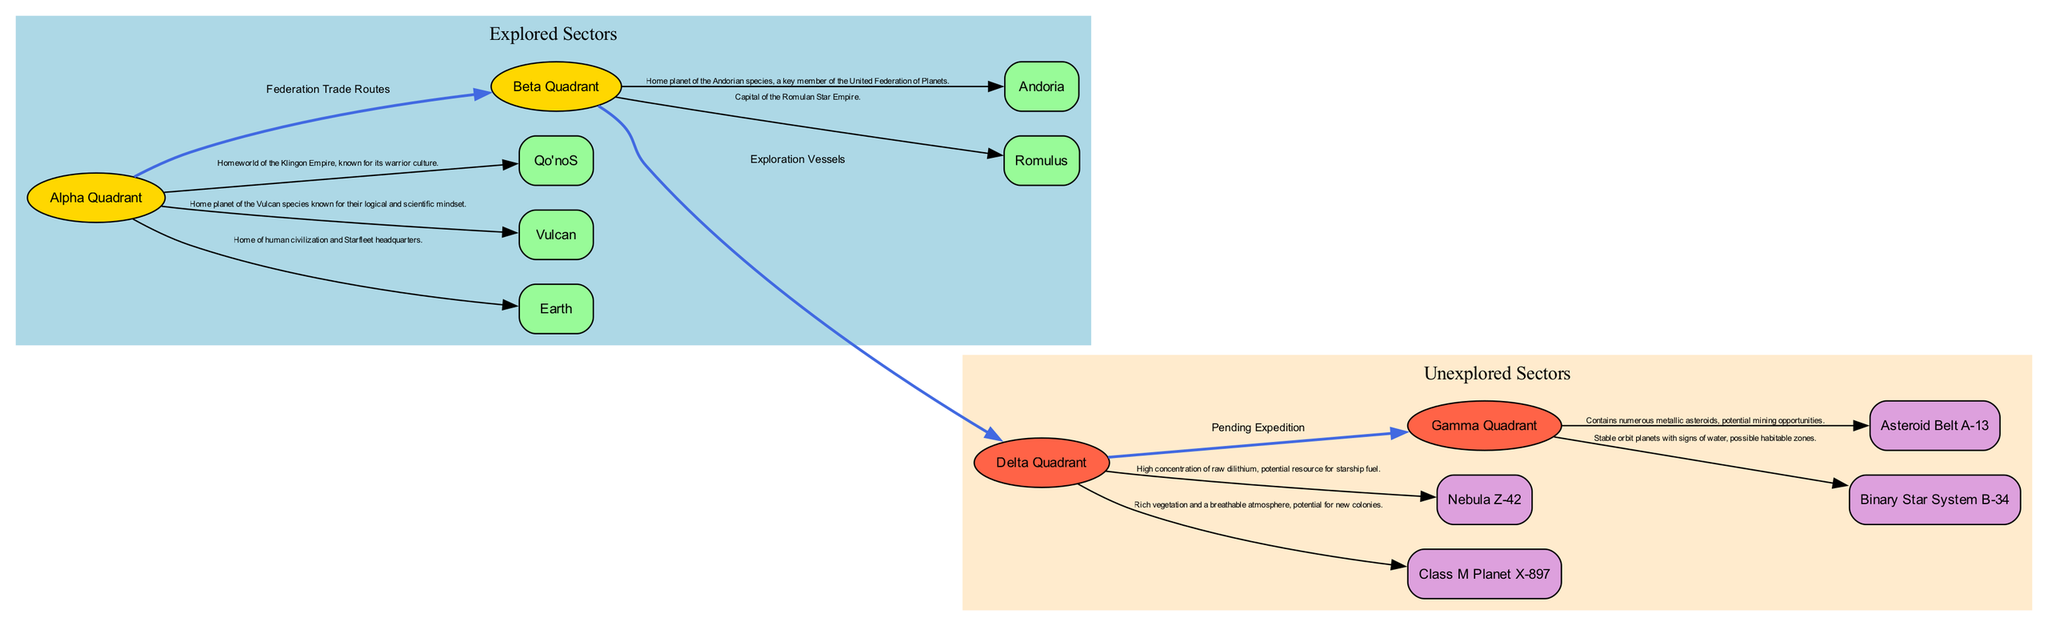What sectors of the galaxy are explored? The diagram lists the explored sectors under the "Explored Sectors" section, specifically highlighting the Alpha Quadrant and the Beta Quadrant as explored areas.
Answer: Alpha Quadrant, Beta Quadrant How many key discoveries are noted in the Alpha Quadrant? Within the Alpha Quadrant section of the diagram, there are three key discoveries annotated: Earth, Vulcan, and Qo'noS.
Answer: 3 What potential habitats are identified in the Delta Quadrant? The Delta Quadrant section of the diagram showcases two potential habitats: Class M Planet X-897 and Nebula Z-42.
Answer: Class M Planet X-897, Nebula Z-42 What is the relationship label between the Beta Quadrant and Delta Quadrant? By examining the edge connecting these two quadrants, the relationship is labeled "Exploration Vessels," indicating the means of travel or exploration.
Answer: Exploration Vessels Which sector contains the home planet of the Vulcan species? The diagram indicates that Vulcan is a key discovery located within the Alpha Quadrant, as noted in the key discoveries annotations.
Answer: Alpha Quadrant What type of resource is highlighted in Nebula Z-42? The diagram specifies that Nebula Z-42 has a high concentration of raw dilithium, indicating its potential as a fuel resource.
Answer: Raw dilithium How many unexplored sectors are there in the galaxy according to the diagram? The diagram lists two unexplored sectors: Delta Quadrant and Gamma Quadrant under the "Unexplored Sectors" section.
Answer: 2 Which edge connects the Delta Quadrant to the Gamma Quadrant? The diagram shows an edge with the label "Pending Expedition" connecting the Delta Quadrant to the Gamma Quadrant, indicating a planned exploration effort.
Answer: Pending Expedition What is the significance of Class M Planet X-897 as noted in the diagram? Class M Planet X-897 is specified to have rich vegetation and a breathable atmosphere, suggesting its potential for new colonies, which is a critical aspect for new life exploration.
Answer: Potential for new colonies 